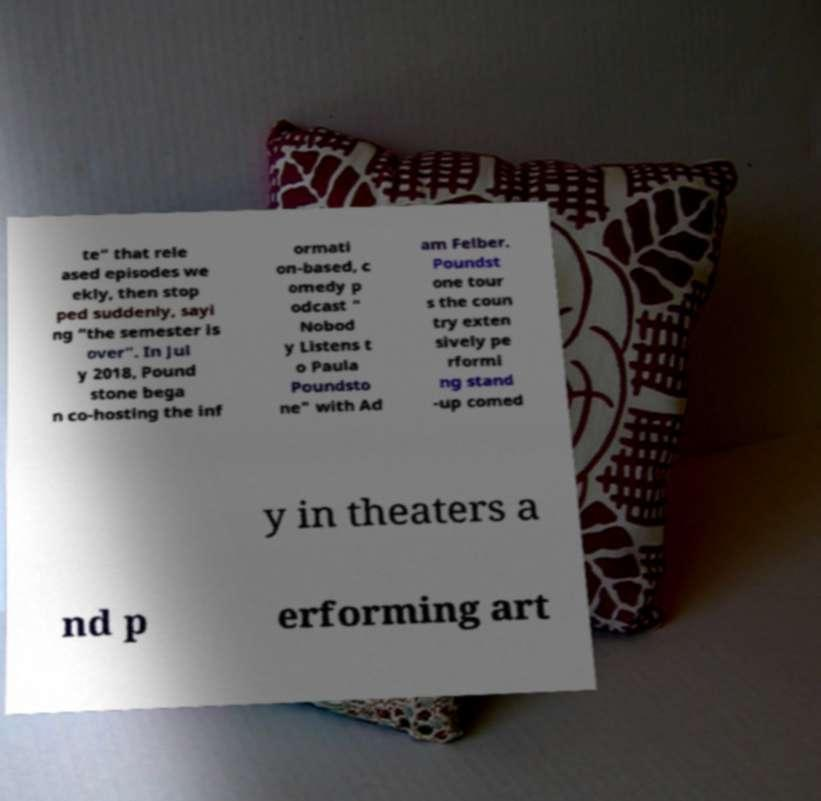For documentation purposes, I need the text within this image transcribed. Could you provide that? te" that rele ased episodes we ekly, then stop ped suddenly, sayi ng “the semester is over”. In Jul y 2018, Pound stone bega n co-hosting the inf ormati on-based, c omedy p odcast " Nobod y Listens t o Paula Poundsto ne" with Ad am Felber. Poundst one tour s the coun try exten sively pe rformi ng stand -up comed y in theaters a nd p erforming art 